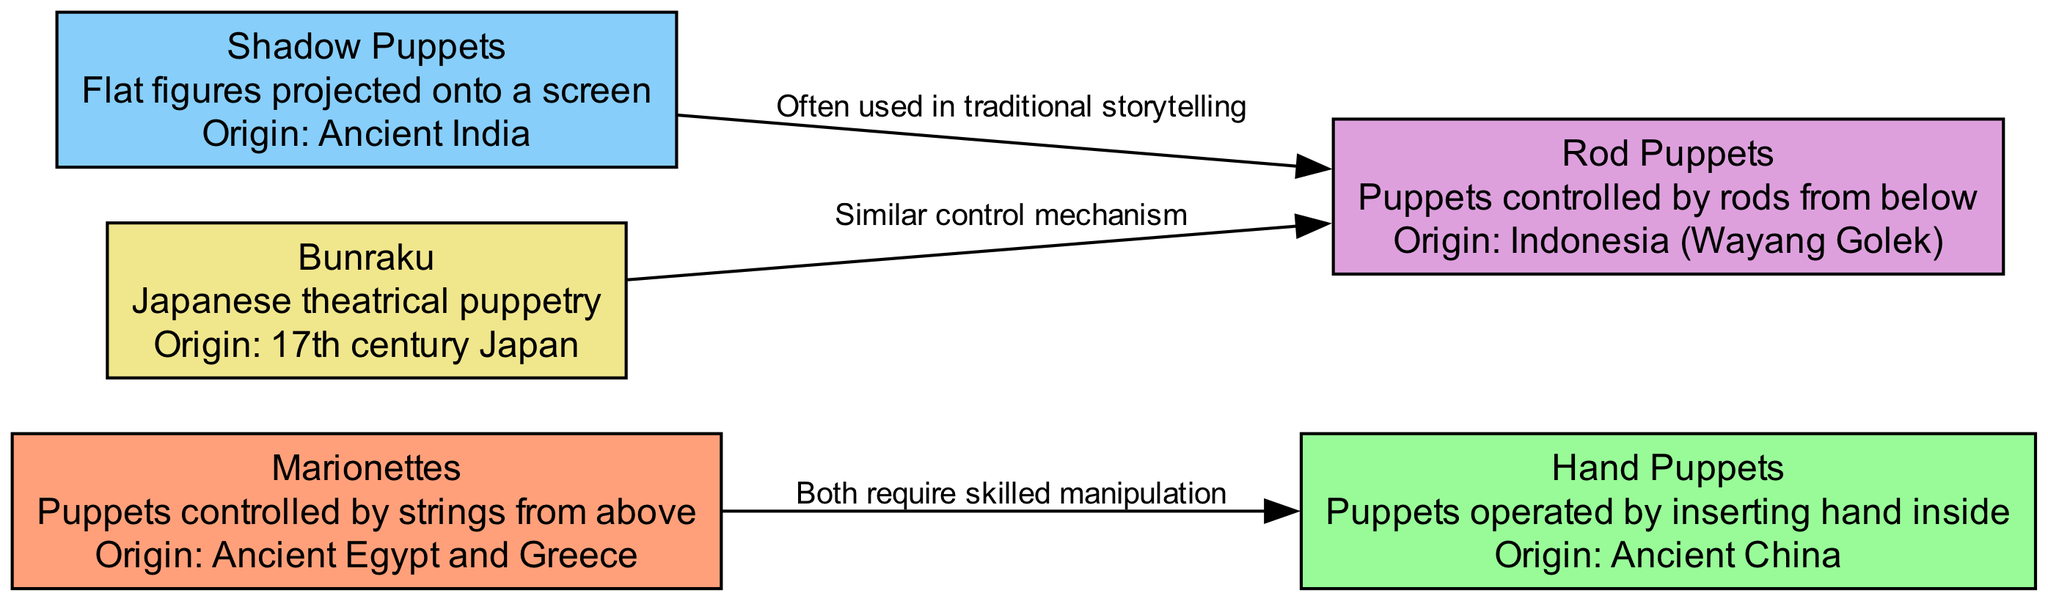What type of puppets are controlled by strings from above? The node labeled "Marionettes" in the diagram describes puppets that are operated by strings. It includes the description and specifies the mechanism of control.
Answer: Marionettes Which two puppet types are said to require skilled manipulation? The edges connecting "Marionettes" and "Hand Puppets" indicate that both types require skilled manipulation as per the label of the connecting edge.
Answer: Marionettes and Hand Puppets How many puppet types are listed in the diagram? By counting the nodes in the diagram, there are a total of five puppet types portrayed, as indicated by the "nodes" section of the data.
Answer: 5 In which region did Shadow Puppets originate? The "Shadow Puppets" node specifies that these puppets originated in Ancient India, which answers the question by referring to the origin information provided.
Answer: Ancient India What is the relationship between Shadow Puppets and Rod Puppets? The edge between "Shadow Puppets" and "Rod Puppets" states that they are often used in traditional storytelling, revealing the purpose they serve within the context of the diagram.
Answer: Often used in traditional storytelling What is the unique feature of Bunraku puppetry compared to other types? Bunraku is labeled as "Japanese theatrical puppetry" in the diagram, distinguishing it as a specific cultural form of puppetry that is different in style and origin from others.
Answer: Japanese theatrical puppetry Which puppet type shares a similar control mechanism with Rod Puppets? The edge from "Bunraku" to "Rod Puppets" indicates that Bunraku shares a similar control mechanism, which provides the required answer by referring back to the edge label.
Answer: Bunraku What is the origin of Hand Puppets? The node detailing "Hand Puppets" specifically mentions their origin as Ancient China, providing the direct answer to the question.
Answer: Ancient China Which puppet uses flat figures projected onto a screen? The "Shadow Puppets" node defines them as flat figures that are projected onto a screen, resulting in a direct answer based on the description.
Answer: Shadow Puppets 